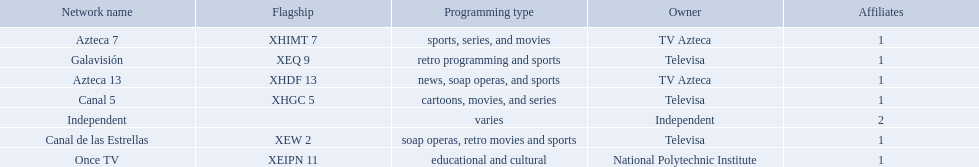What station shows cartoons? Canal 5. What station shows soap operas? Canal de las Estrellas. What station shows sports? Azteca 7. What television stations are in morelos? Canal de las Estrellas, Canal 5, Azteca 7, Galavisión, Once TV, Azteca 13, Independent. Of those which network is owned by national polytechnic institute? Once TV. 